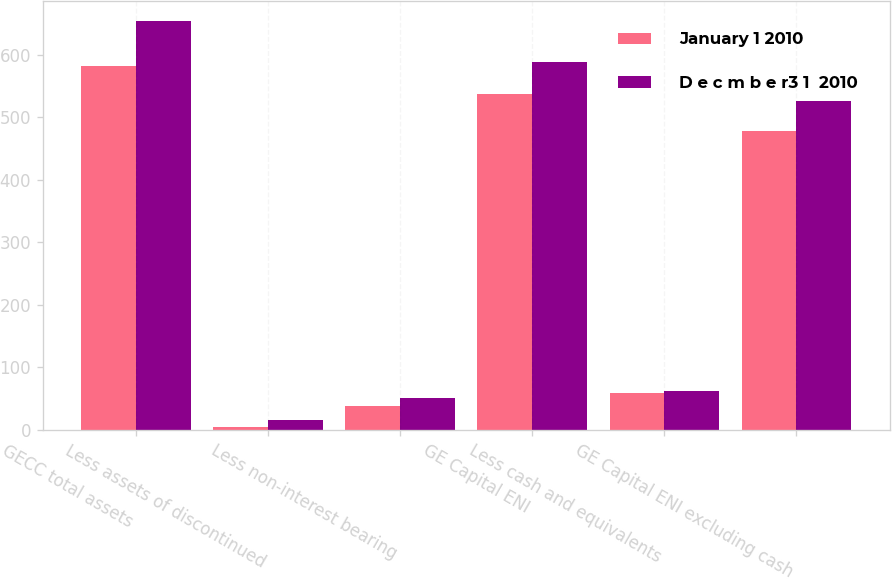<chart> <loc_0><loc_0><loc_500><loc_500><stacked_bar_chart><ecel><fcel>GECC total assets<fcel>Less assets of discontinued<fcel>Less non-interest bearing<fcel>GE Capital ENI<fcel>Less cash and equivalents<fcel>GE Capital ENI excluding cash<nl><fcel>January 1 2010<fcel>581.1<fcel>5.2<fcel>38.9<fcel>537<fcel>59.6<fcel>477.4<nl><fcel>D e c m b e r3 1  2010<fcel>653.6<fcel>15.1<fcel>50.3<fcel>588.2<fcel>61.9<fcel>526.3<nl></chart> 